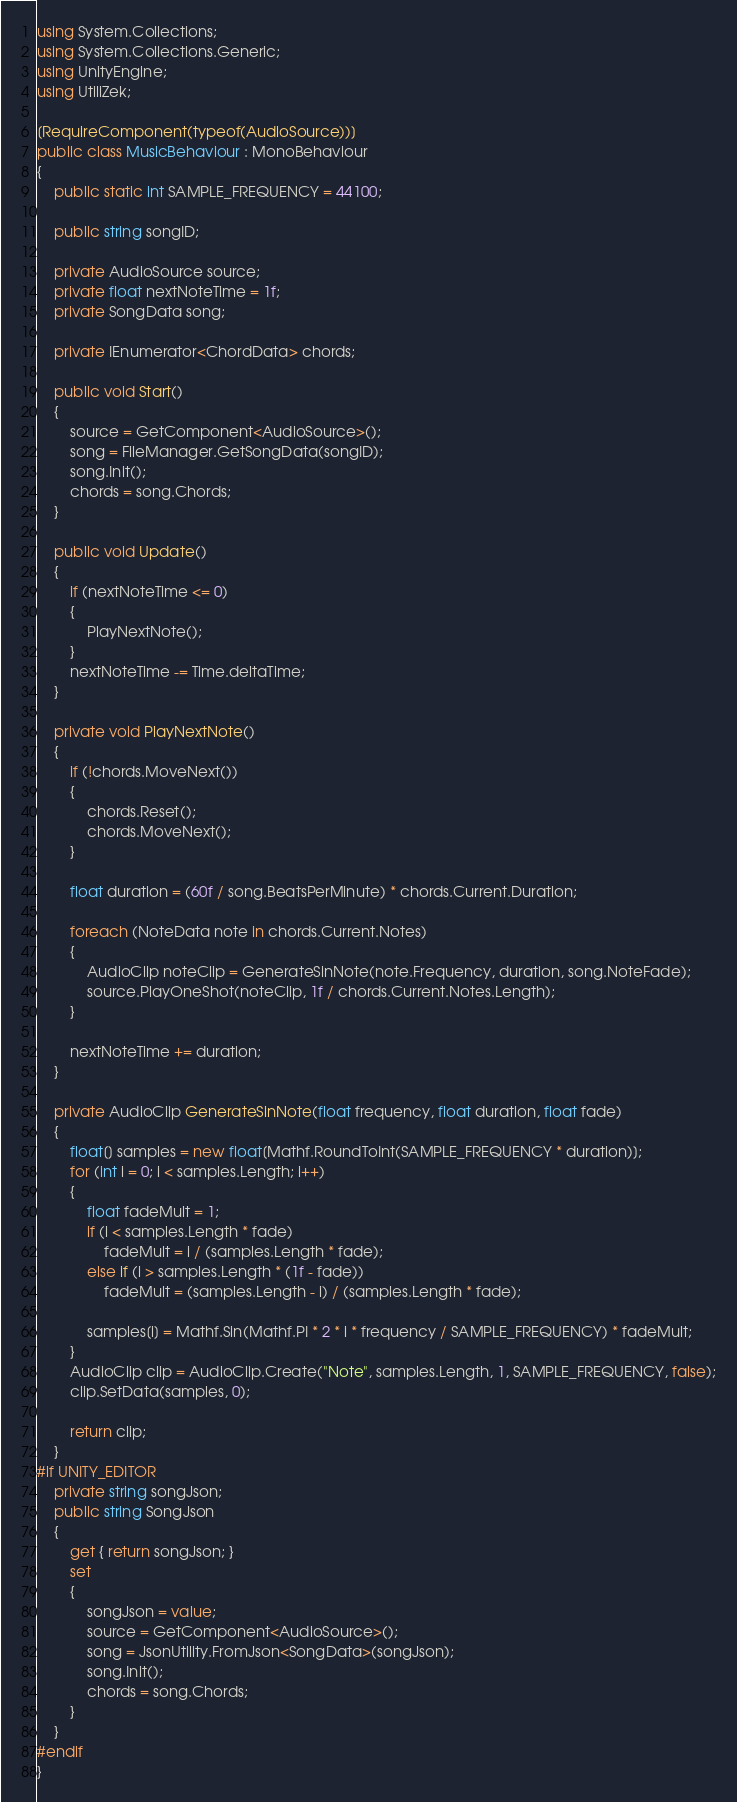<code> <loc_0><loc_0><loc_500><loc_500><_C#_>using System.Collections;
using System.Collections.Generic;
using UnityEngine;
using UtiliZek;

[RequireComponent(typeof(AudioSource))]
public class MusicBehaviour : MonoBehaviour
{
    public static int SAMPLE_FREQUENCY = 44100;

    public string songID;

    private AudioSource source;
    private float nextNoteTime = 1f;
    private SongData song;

    private IEnumerator<ChordData> chords;

    public void Start()
    {
        source = GetComponent<AudioSource>();
        song = FileManager.GetSongData(songID);
        song.Init();
        chords = song.Chords;
    }

    public void Update()
    {
        if (nextNoteTime <= 0)
        {
            PlayNextNote();
        }
        nextNoteTime -= Time.deltaTime;
    }

    private void PlayNextNote()
    {
        if (!chords.MoveNext())
        {
            chords.Reset();
            chords.MoveNext();
        }

        float duration = (60f / song.BeatsPerMinute) * chords.Current.Duration;

        foreach (NoteData note in chords.Current.Notes)
        {
            AudioClip noteClip = GenerateSinNote(note.Frequency, duration, song.NoteFade);
            source.PlayOneShot(noteClip, 1f / chords.Current.Notes.Length);
        }

        nextNoteTime += duration;
    }

    private AudioClip GenerateSinNote(float frequency, float duration, float fade)
    {
        float[] samples = new float[Mathf.RoundToInt(SAMPLE_FREQUENCY * duration)];
        for (int i = 0; i < samples.Length; i++)
        {
            float fadeMult = 1;
            if (i < samples.Length * fade)
                fadeMult = i / (samples.Length * fade);
            else if (i > samples.Length * (1f - fade))
                fadeMult = (samples.Length - i) / (samples.Length * fade);

            samples[i] = Mathf.Sin(Mathf.PI * 2 * i * frequency / SAMPLE_FREQUENCY) * fadeMult;
        }
        AudioClip clip = AudioClip.Create("Note", samples.Length, 1, SAMPLE_FREQUENCY, false);
        clip.SetData(samples, 0);

        return clip;
    }
#if UNITY_EDITOR
    private string songJson;
    public string SongJson
    {
        get { return songJson; }
        set
        {
            songJson = value;
            source = GetComponent<AudioSource>();
            song = JsonUtility.FromJson<SongData>(songJson);
            song.Init();
            chords = song.Chords;
        }
    }
#endif
}</code> 